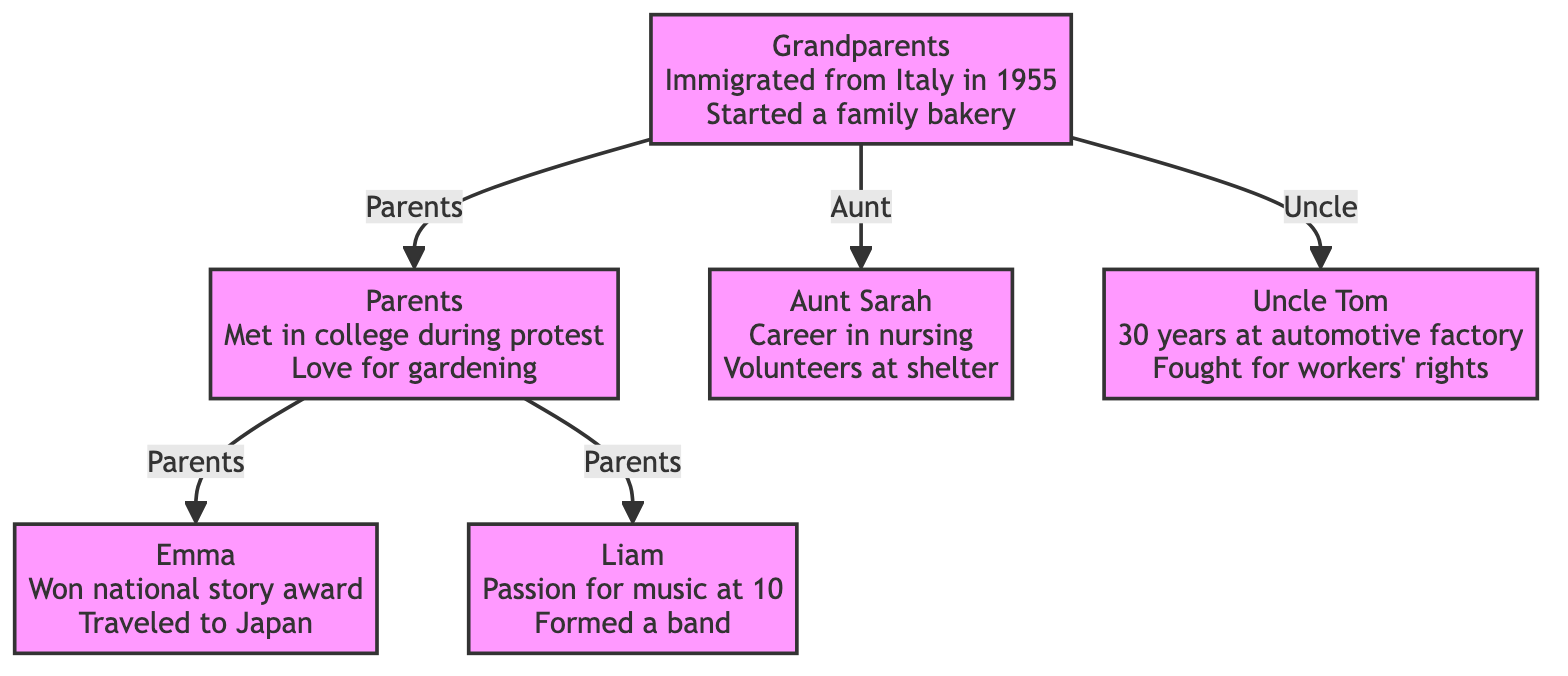What is the relationship between the Grandparents and Parents? The diagram shows a directed edge from "Grandparents" (node 1) to "Parents" (node 2) marked with "Parents," indicating that the relationship is that of parent to child.
Answer: Parents How many children do the Parents have? The Parents (node 2) lead to two nodes: "Child 1: Emma" (node 3) and "Child 2: Liam" (node 4). Therefore, they have two children.
Answer: 2 What significant story is associated with Aunt Sarah? Looking at the stories listed under "Aunt: Sarah" (node 5), the significant story is her career in nursing after losing a close friend, which is explicitly mentioned.
Answer: Career in nursing Who is Uncle Tom's relation to the Grandparents? The diagram has a direct edge from "Grandparents" (node 1) to "Uncle: Tom" (node 6), which is labeled "Uncle," showing that he is the uncle of the Parents.
Answer: Uncle Which child traveled to Japan? The stories listed under "Child 1: Emma" (node 3) highlight her travel to Japan as part of her significant life events.
Answer: Emma How many nodes are connected to the Grandparents? The Grandparents (node 1) have three direct connections: one to the Parents, one to Aunt Sarah, and one to Uncle Tom, resulting in a total of three nodes connected to them.
Answer: 3 What shared interest do the Parents have? The stories associated with the "Parents" (node 2) mention their shared passionate love for gardening and sustainability, which is a key element of their narrative.
Answer: Gardening How many generations are represented in this family tree? The diagram features three generations: Grandparents as the first generation, Parents as the second, and Emma and Liam as the third. Thus, there are three generations represented.
Answer: 3 Which child has a passion for music? The stories linked to "Child 2: Liam" (node 4) mention that he discovered a passion for music at age 10, indicating his interest in this field.
Answer: Liam 